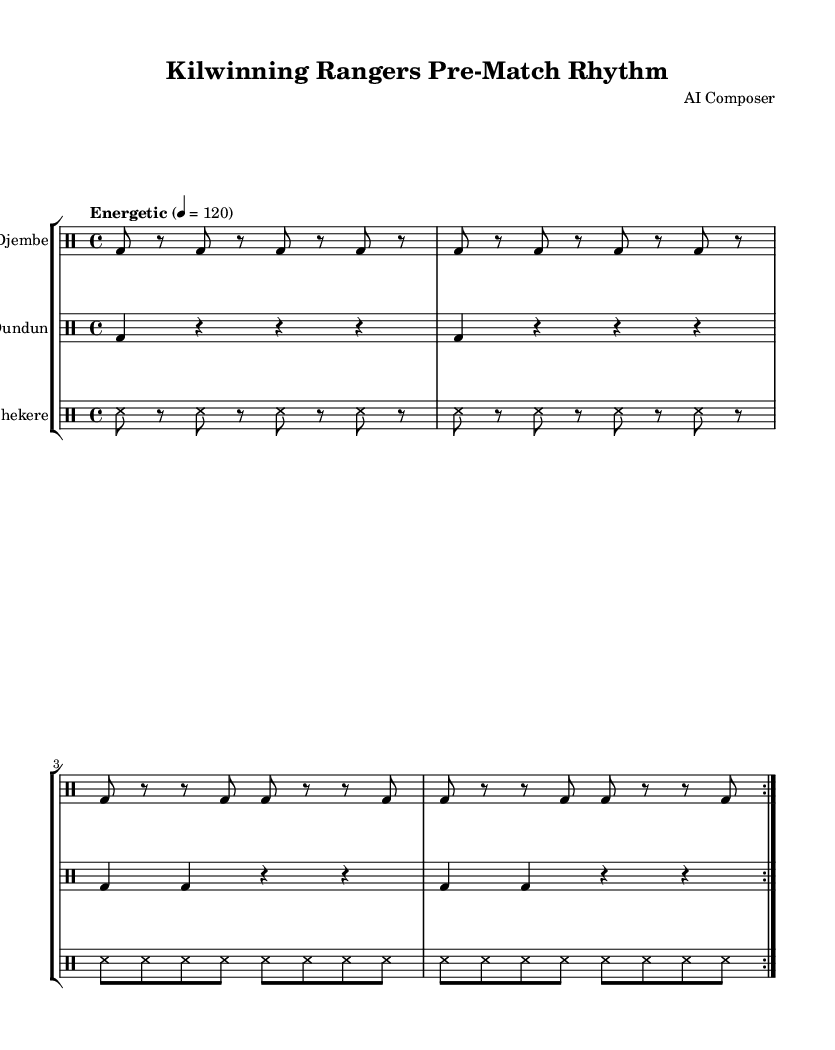What is the key signature of this music? The key signature is C major, which has no sharps or flats.
Answer: C major What is the time signature of this piece? The time signature is specified as 4/4, meaning there are four beats in each measure.
Answer: 4/4 What is the tempo marking for this music? The tempo marking indicates a speed of 120 beats per minute, described as "Energetic".
Answer: Energetic 4 = 120 How many measures are repeated for the djembe part? The djembe part has a repeat sign and is indicated to repeat for a total of two measures.
Answer: 2 What instrument is marked with the highest rhythm density? The shekere is played with denser rhythmic activity, having continuous 16th notes.
Answer: Shekere What is the rhythmic value primarily used in the djembe section? The djembe section predominantly features eighth notes, which are indicated by "8" in the notation.
Answer: Eighth notes Which instrument plays the longest rhythmic values? The dundun employs quarter note rhythms, which are the longest in comparison to the djembe and shekere.
Answer: Dundun 